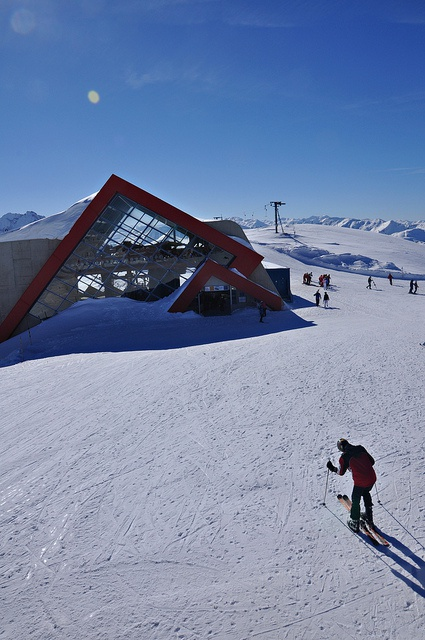Describe the objects in this image and their specific colors. I can see people in gray, black, maroon, and lavender tones, skis in gray, black, darkgray, and brown tones, people in gray, darkgray, and black tones, people in black, navy, darkblue, and gray tones, and people in gray, black, navy, and darkgray tones in this image. 